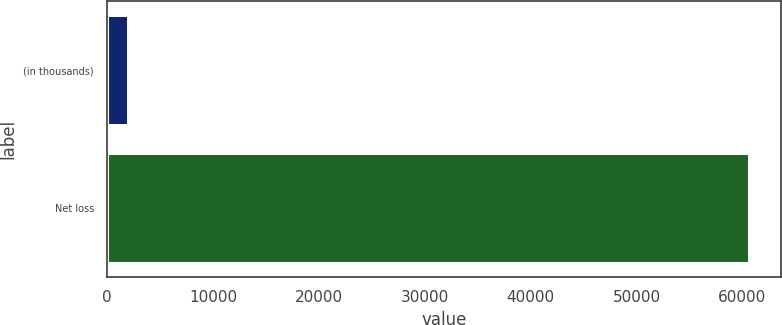Convert chart to OTSL. <chart><loc_0><loc_0><loc_500><loc_500><bar_chart><fcel>(in thousands)<fcel>Net loss<nl><fcel>2008<fcel>60581<nl></chart> 